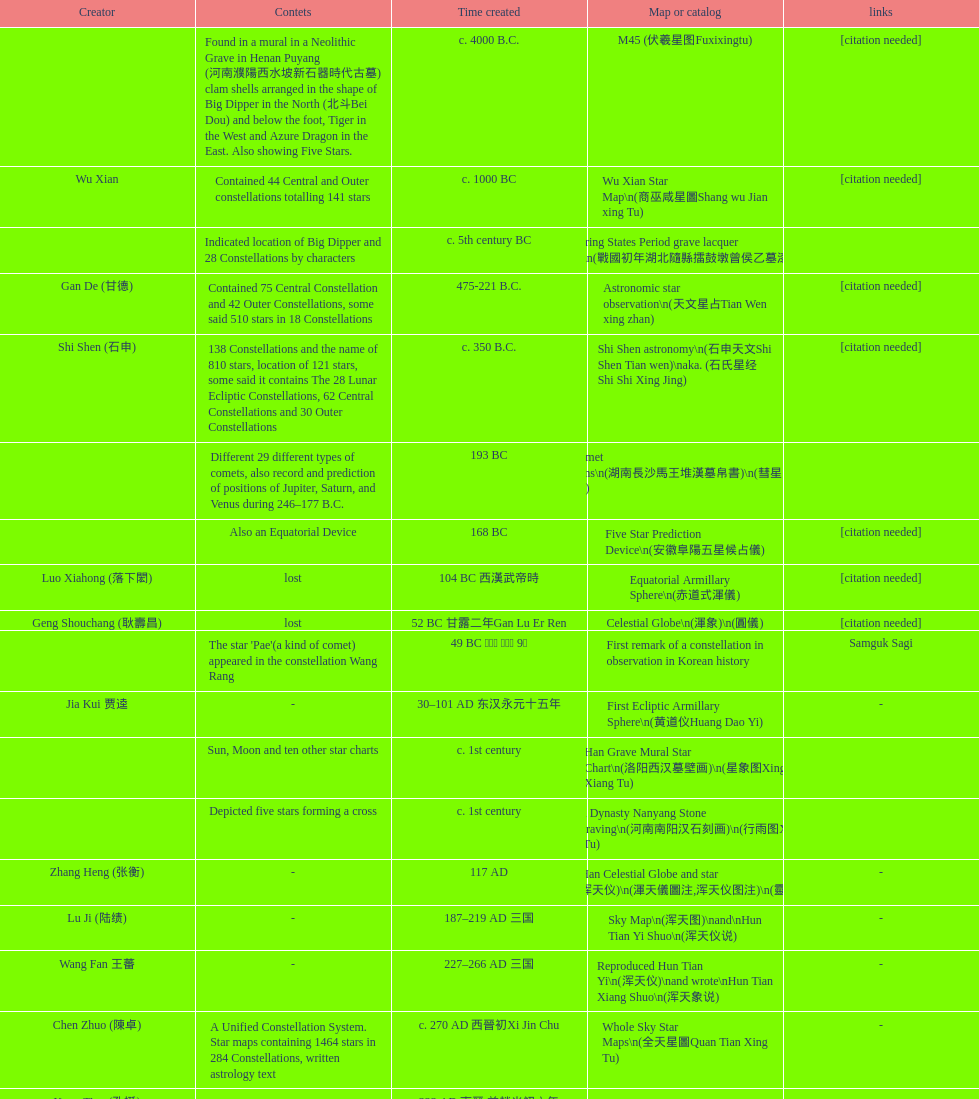When was the first map or catalog created? C. 4000 b.c. 